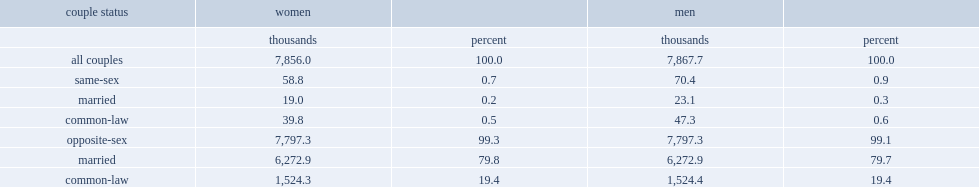How many thousands were women in same-sex couples by 2011? 58.8. How many thousands have women been common-law among those in same-sex couples by 2011? 39.8. How many thousands have women been married spouses among those in same-sex couples by 2011? 19.0. How many percentage points did women living in a same-sex union represent in all women in couples in canada in 2011? 0.7. How many percentage points did men living in a same-sex union represent among all men in couples in canada in 2011? 0.9. 